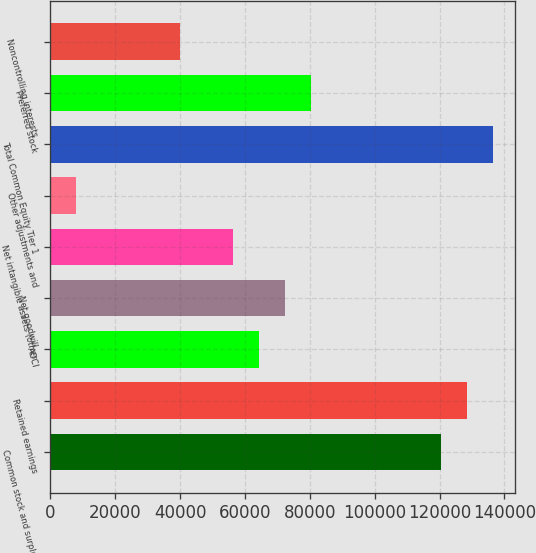Convert chart. <chart><loc_0><loc_0><loc_500><loc_500><bar_chart><fcel>Common stock and surplus<fcel>Retained earnings<fcel>AOCI<fcel>Net goodwill<fcel>Net intangible assets (other<fcel>Other adjustments and<fcel>Total Common Equity Tier 1<fcel>Preferred stock<fcel>Noncontrolling interests<nl><fcel>120408<fcel>128435<fcel>64221.6<fcel>72248.3<fcel>56194.9<fcel>8034.7<fcel>136462<fcel>80275<fcel>40141.5<nl></chart> 